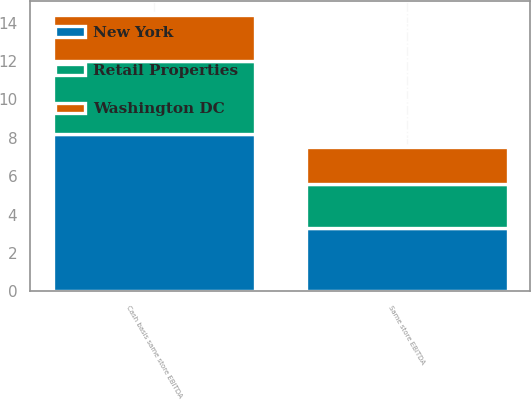Convert chart. <chart><loc_0><loc_0><loc_500><loc_500><stacked_bar_chart><ecel><fcel>Same store EBITDA<fcel>Cash basis same store EBITDA<nl><fcel>New York<fcel>3.3<fcel>8.2<nl><fcel>Retail Properties<fcel>2.3<fcel>3.8<nl><fcel>Washington DC<fcel>1.9<fcel>2.4<nl></chart> 